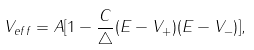<formula> <loc_0><loc_0><loc_500><loc_500>V _ { e f f } = A [ 1 - \frac { C } { \triangle } ( E - V _ { + } ) ( E - V _ { - } ) ] ,</formula> 